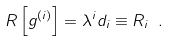Convert formula to latex. <formula><loc_0><loc_0><loc_500><loc_500>R \left [ g ^ { ( i ) } \right ] = \lambda ^ { i } d _ { i } \equiv R _ { i } \ .</formula> 